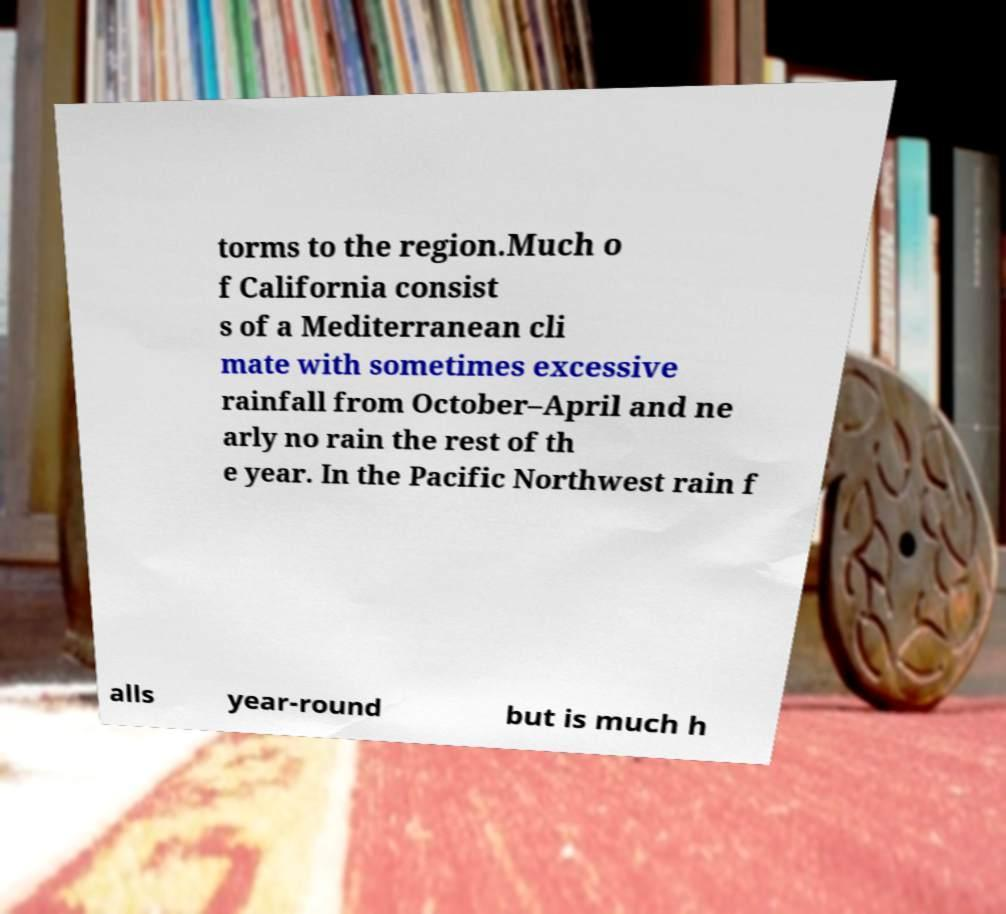I need the written content from this picture converted into text. Can you do that? torms to the region.Much o f California consist s of a Mediterranean cli mate with sometimes excessive rainfall from October–April and ne arly no rain the rest of th e year. In the Pacific Northwest rain f alls year-round but is much h 